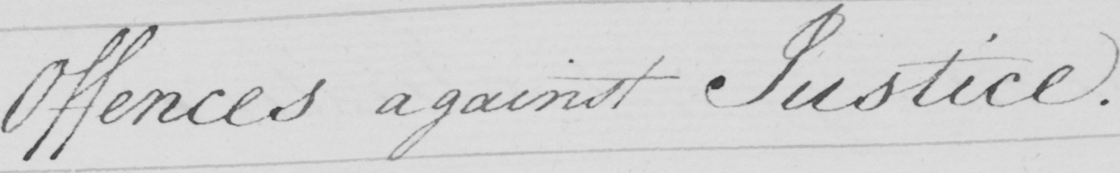Please transcribe the handwritten text in this image. Offences against Justice. 